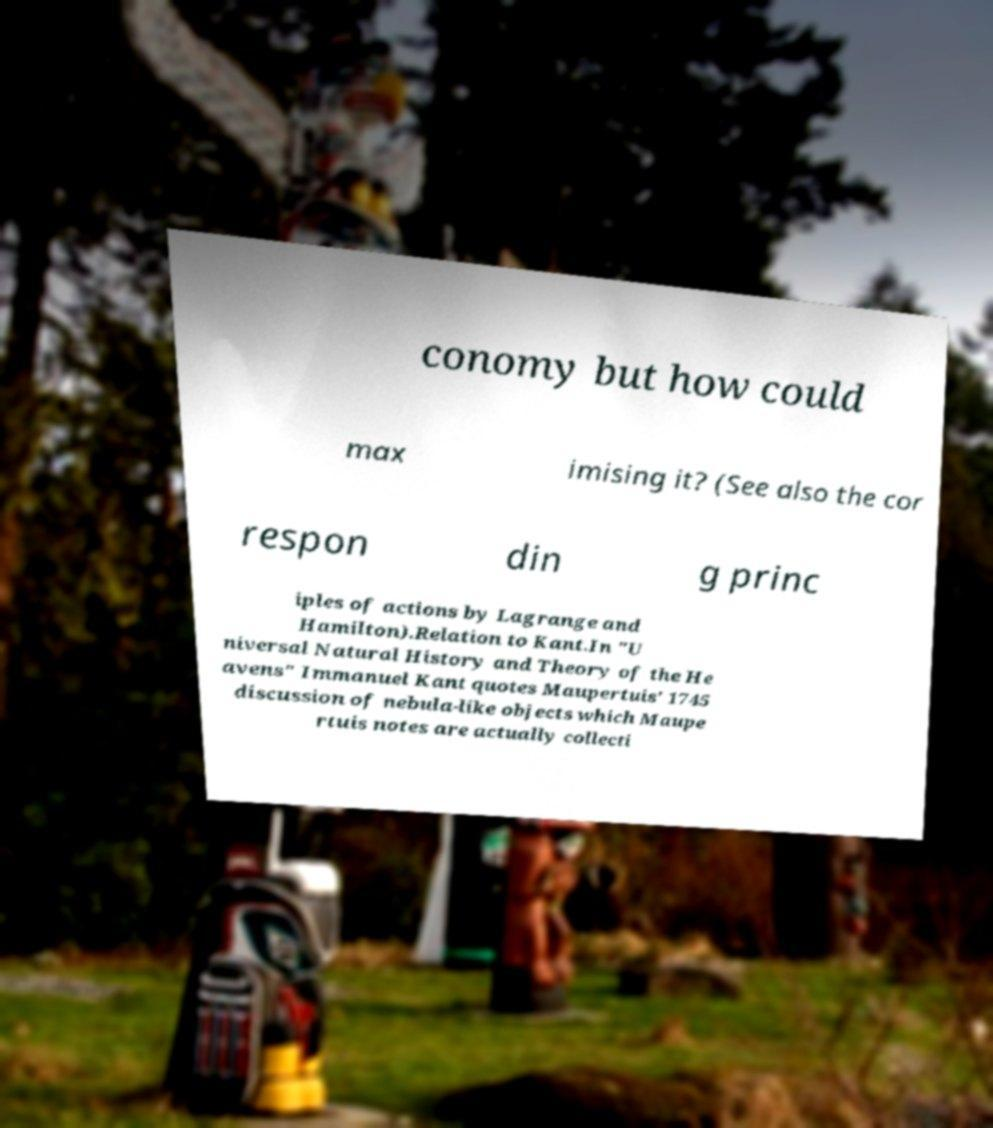For documentation purposes, I need the text within this image transcribed. Could you provide that? conomy but how could max imising it? (See also the cor respon din g princ iples of actions by Lagrange and Hamilton).Relation to Kant.In "U niversal Natural History and Theory of the He avens" Immanuel Kant quotes Maupertuis' 1745 discussion of nebula-like objects which Maupe rtuis notes are actually collecti 